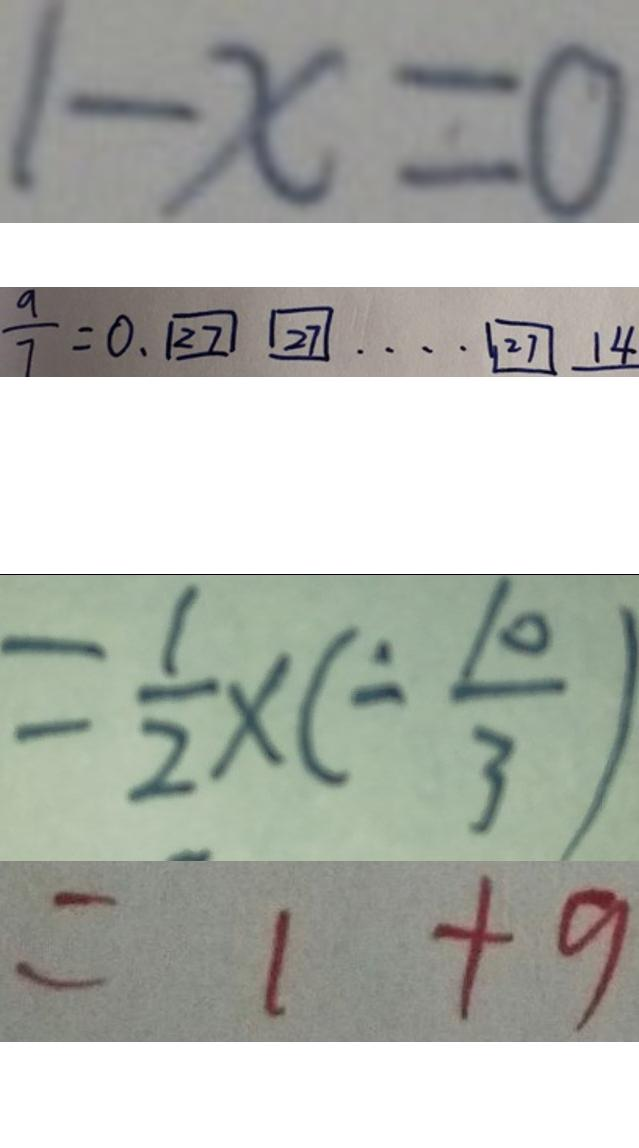Convert formula to latex. <formula><loc_0><loc_0><loc_500><loc_500>1 - x = 0 
 \frac { 9 } { 7 } = 0 . \boxed { 2 7 } \boxed { 2 7 } \cdots \boxed { 2 7 } 1 4 
 = \frac { 1 } { 2 } \times ( - \frac { 1 0 } { 3 } ) 
 = 1 + 9</formula> 